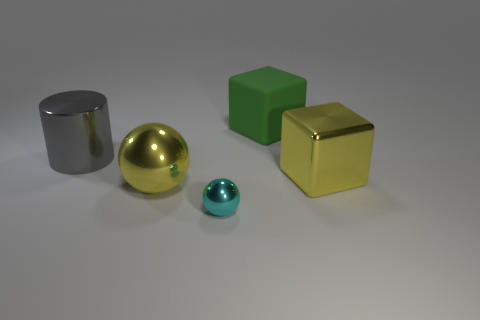How many large green things are there?
Offer a very short reply. 1. Do the tiny sphere and the metallic cube have the same color?
Give a very brief answer. No. What color is the large thing that is both behind the large yellow metal cube and to the left of the large green cube?
Provide a short and direct response. Gray. There is a small metallic object; are there any matte objects in front of it?
Provide a succinct answer. No. What number of green objects are on the right side of the yellow shiny thing that is to the right of the green matte thing?
Ensure brevity in your answer.  0. What is the size of the yellow cube that is made of the same material as the gray cylinder?
Your answer should be compact. Large. What is the size of the cyan object?
Make the answer very short. Small. Is the large yellow block made of the same material as the green thing?
Give a very brief answer. No. How many blocks are tiny cyan rubber things or green rubber objects?
Your response must be concise. 1. The big shiny thing on the left side of the big metal thing in front of the metal block is what color?
Your answer should be compact. Gray. 